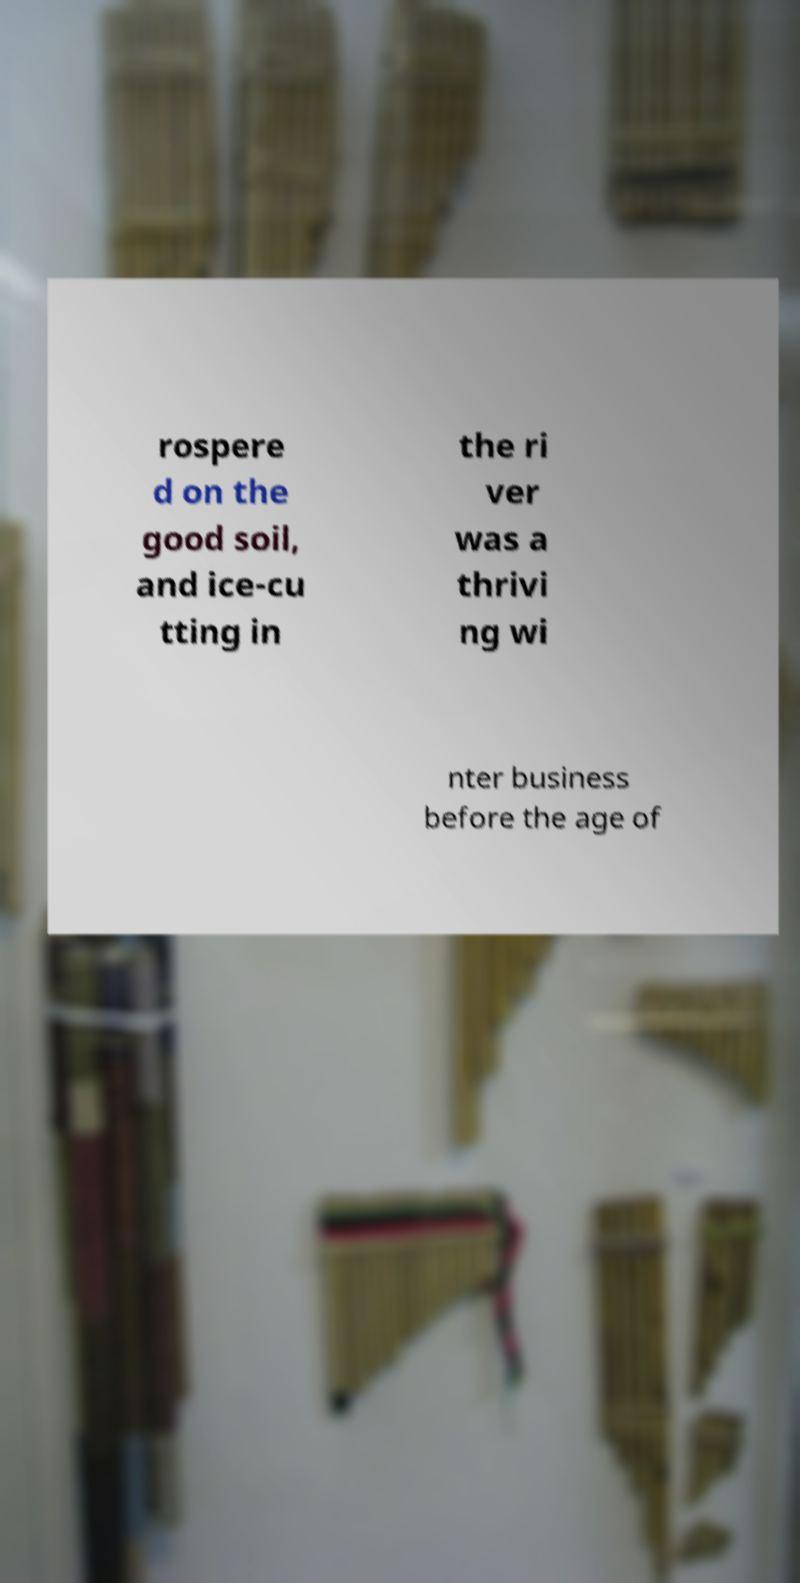Can you accurately transcribe the text from the provided image for me? rospere d on the good soil, and ice-cu tting in the ri ver was a thrivi ng wi nter business before the age of 